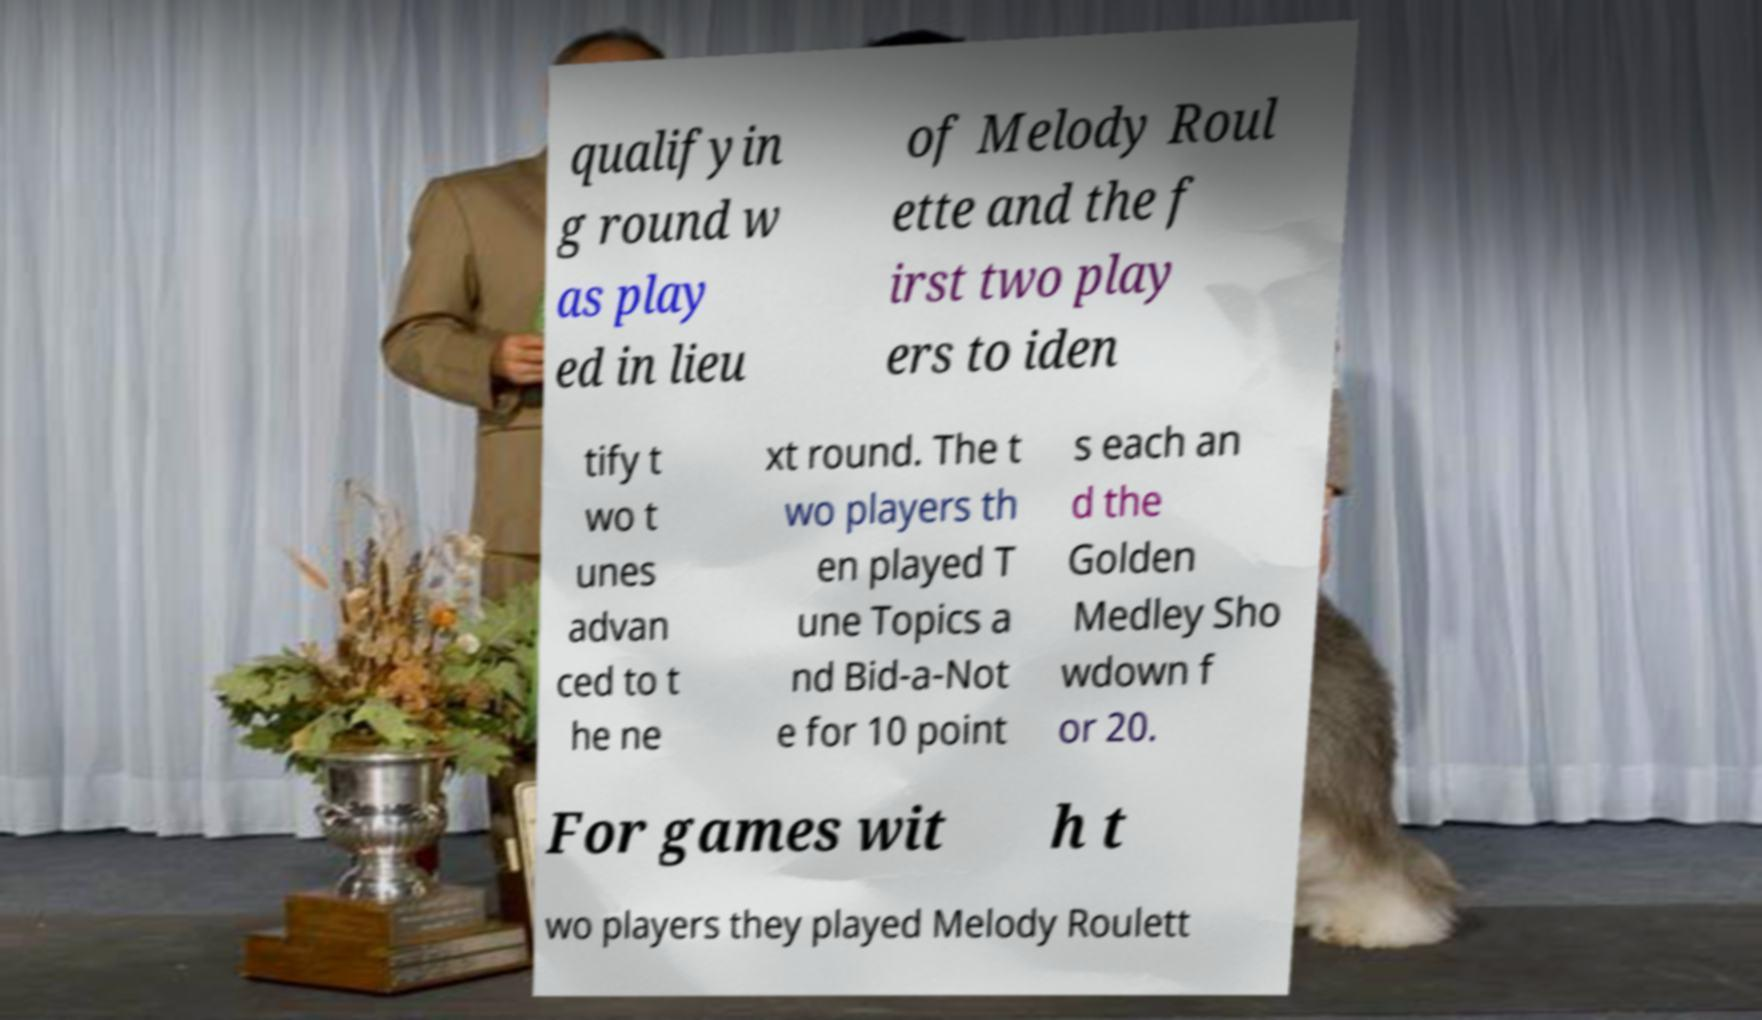Please read and relay the text visible in this image. What does it say? qualifyin g round w as play ed in lieu of Melody Roul ette and the f irst two play ers to iden tify t wo t unes advan ced to t he ne xt round. The t wo players th en played T une Topics a nd Bid-a-Not e for 10 point s each an d the Golden Medley Sho wdown f or 20. For games wit h t wo players they played Melody Roulett 